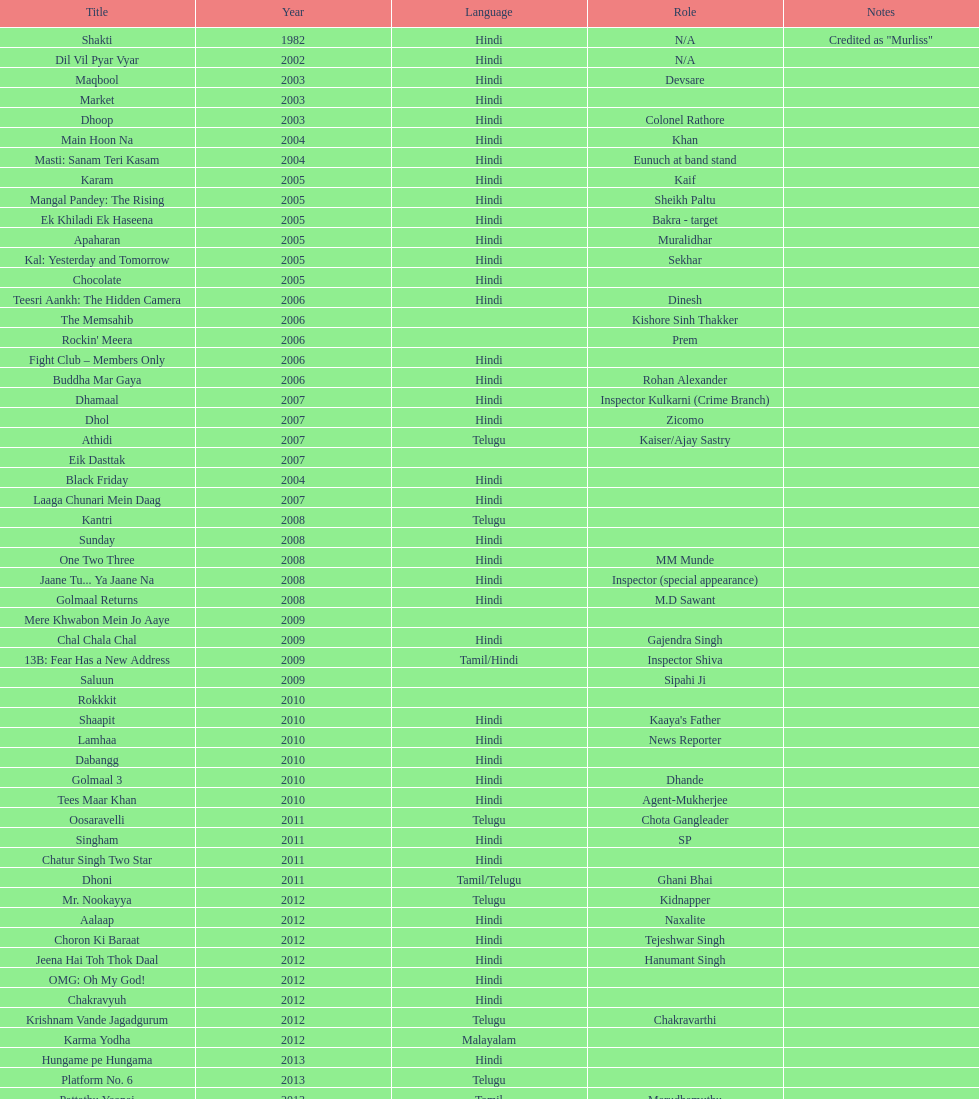Help me parse the entirety of this table. {'header': ['Title', 'Year', 'Language', 'Role', 'Notes'], 'rows': [['Shakti', '1982', 'Hindi', 'N/A', 'Credited as "Murliss"'], ['Dil Vil Pyar Vyar', '2002', 'Hindi', 'N/A', ''], ['Maqbool', '2003', 'Hindi', 'Devsare', ''], ['Market', '2003', 'Hindi', '', ''], ['Dhoop', '2003', 'Hindi', 'Colonel Rathore', ''], ['Main Hoon Na', '2004', 'Hindi', 'Khan', ''], ['Masti: Sanam Teri Kasam', '2004', 'Hindi', 'Eunuch at band stand', ''], ['Karam', '2005', 'Hindi', 'Kaif', ''], ['Mangal Pandey: The Rising', '2005', 'Hindi', 'Sheikh Paltu', ''], ['Ek Khiladi Ek Haseena', '2005', 'Hindi', 'Bakra - target', ''], ['Apaharan', '2005', 'Hindi', 'Muralidhar', ''], ['Kal: Yesterday and Tomorrow', '2005', 'Hindi', 'Sekhar', ''], ['Chocolate', '2005', 'Hindi', '', ''], ['Teesri Aankh: The Hidden Camera', '2006', 'Hindi', 'Dinesh', ''], ['The Memsahib', '2006', '', 'Kishore Sinh Thakker', ''], ["Rockin' Meera", '2006', '', 'Prem', ''], ['Fight Club – Members Only', '2006', 'Hindi', '', ''], ['Buddha Mar Gaya', '2006', 'Hindi', 'Rohan Alexander', ''], ['Dhamaal', '2007', 'Hindi', 'Inspector Kulkarni (Crime Branch)', ''], ['Dhol', '2007', 'Hindi', 'Zicomo', ''], ['Athidi', '2007', 'Telugu', 'Kaiser/Ajay Sastry', ''], ['Eik Dasttak', '2007', '', '', ''], ['Black Friday', '2004', 'Hindi', '', ''], ['Laaga Chunari Mein Daag', '2007', 'Hindi', '', ''], ['Kantri', '2008', 'Telugu', '', ''], ['Sunday', '2008', 'Hindi', '', ''], ['One Two Three', '2008', 'Hindi', 'MM Munde', ''], ['Jaane Tu... Ya Jaane Na', '2008', 'Hindi', 'Inspector (special appearance)', ''], ['Golmaal Returns', '2008', 'Hindi', 'M.D Sawant', ''], ['Mere Khwabon Mein Jo Aaye', '2009', '', '', ''], ['Chal Chala Chal', '2009', 'Hindi', 'Gajendra Singh', ''], ['13B: Fear Has a New Address', '2009', 'Tamil/Hindi', 'Inspector Shiva', ''], ['Saluun', '2009', '', 'Sipahi Ji', ''], ['Rokkkit', '2010', '', '', ''], ['Shaapit', '2010', 'Hindi', "Kaaya's Father", ''], ['Lamhaa', '2010', 'Hindi', 'News Reporter', ''], ['Dabangg', '2010', 'Hindi', '', ''], ['Golmaal 3', '2010', 'Hindi', 'Dhande', ''], ['Tees Maar Khan', '2010', 'Hindi', 'Agent-Mukherjee', ''], ['Oosaravelli', '2011', 'Telugu', 'Chota Gangleader', ''], ['Singham', '2011', 'Hindi', 'SP', ''], ['Chatur Singh Two Star', '2011', 'Hindi', '', ''], ['Dhoni', '2011', 'Tamil/Telugu', 'Ghani Bhai', ''], ['Mr. Nookayya', '2012', 'Telugu', 'Kidnapper', ''], ['Aalaap', '2012', 'Hindi', 'Naxalite', ''], ['Choron Ki Baraat', '2012', 'Hindi', 'Tejeshwar Singh', ''], ['Jeena Hai Toh Thok Daal', '2012', 'Hindi', 'Hanumant Singh', ''], ['OMG: Oh My God!', '2012', 'Hindi', '', ''], ['Chakravyuh', '2012', 'Hindi', '', ''], ['Krishnam Vande Jagadgurum', '2012', 'Telugu', 'Chakravarthi', ''], ['Karma Yodha', '2012', 'Malayalam', '', ''], ['Hungame pe Hungama', '2013', 'Hindi', '', ''], ['Platform No. 6', '2013', 'Telugu', '', ''], ['Pattathu Yaanai', '2013', 'Tamil', 'Marudhamuthu', ''], ['Zindagi 50-50', '2013', 'Hindi', '', ''], ['Yevadu', '2013', 'Telugu', 'Durani', ''], ['Karmachari', '2013', 'Telugu', '', '']]} What was the last malayalam film this actor starred in? Karma Yodha. 